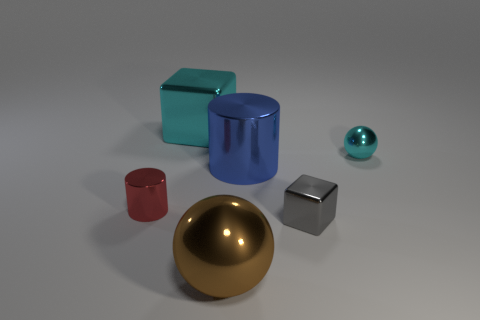Subtract all blocks. How many objects are left? 4 Add 1 cyan metal things. How many objects exist? 7 Subtract all cyan spheres. Subtract all gray cylinders. How many spheres are left? 1 Subtract all metal cylinders. Subtract all cyan shiny cubes. How many objects are left? 3 Add 2 balls. How many balls are left? 4 Add 4 small purple shiny objects. How many small purple shiny objects exist? 4 Subtract 0 brown cubes. How many objects are left? 6 